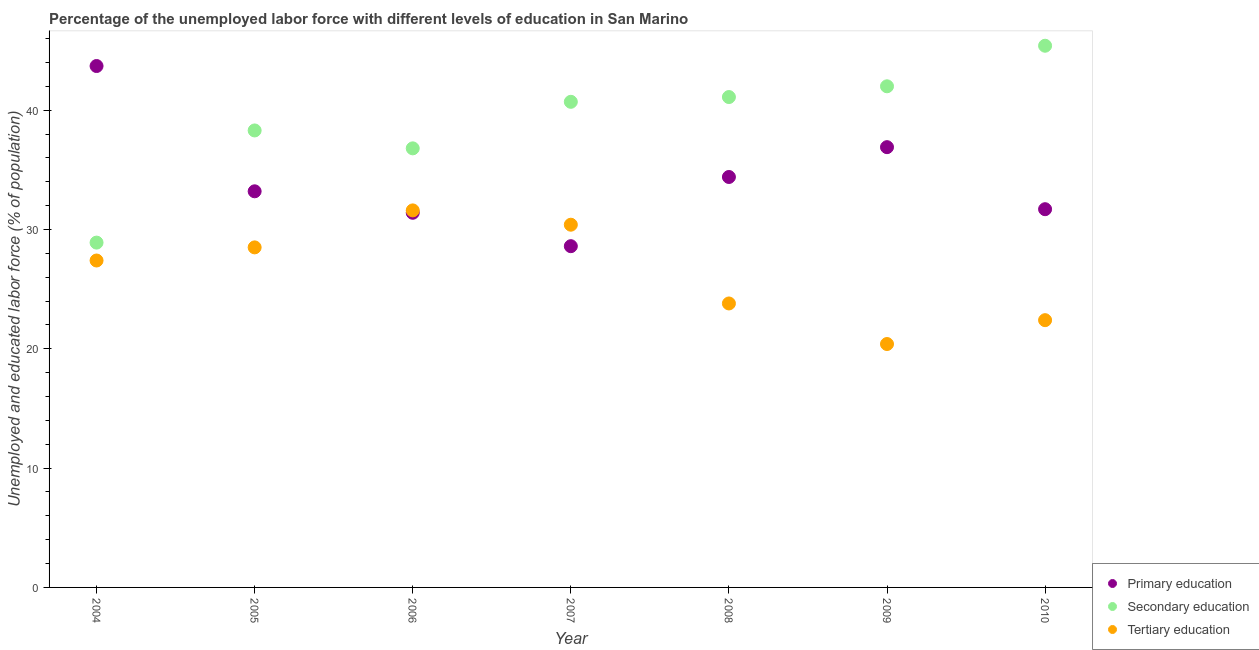Is the number of dotlines equal to the number of legend labels?
Offer a terse response. Yes. What is the percentage of labor force who received tertiary education in 2006?
Ensure brevity in your answer.  31.6. Across all years, what is the maximum percentage of labor force who received tertiary education?
Provide a succinct answer. 31.6. Across all years, what is the minimum percentage of labor force who received secondary education?
Keep it short and to the point. 28.9. In which year was the percentage of labor force who received tertiary education maximum?
Keep it short and to the point. 2006. In which year was the percentage of labor force who received primary education minimum?
Offer a very short reply. 2007. What is the total percentage of labor force who received secondary education in the graph?
Your response must be concise. 273.2. What is the difference between the percentage of labor force who received primary education in 2004 and that in 2006?
Your answer should be very brief. 12.3. What is the difference between the percentage of labor force who received tertiary education in 2007 and the percentage of labor force who received secondary education in 2006?
Provide a short and direct response. -6.4. What is the average percentage of labor force who received tertiary education per year?
Keep it short and to the point. 26.36. In the year 2004, what is the difference between the percentage of labor force who received tertiary education and percentage of labor force who received secondary education?
Provide a succinct answer. -1.5. In how many years, is the percentage of labor force who received primary education greater than 28 %?
Your answer should be compact. 7. What is the ratio of the percentage of labor force who received secondary education in 2005 to that in 2007?
Provide a short and direct response. 0.94. What is the difference between the highest and the second highest percentage of labor force who received primary education?
Offer a terse response. 6.8. What is the difference between the highest and the lowest percentage of labor force who received primary education?
Make the answer very short. 15.1. Is it the case that in every year, the sum of the percentage of labor force who received primary education and percentage of labor force who received secondary education is greater than the percentage of labor force who received tertiary education?
Your answer should be very brief. Yes. Does the percentage of labor force who received tertiary education monotonically increase over the years?
Offer a very short reply. No. Are the values on the major ticks of Y-axis written in scientific E-notation?
Provide a short and direct response. No. Does the graph contain grids?
Your response must be concise. No. Where does the legend appear in the graph?
Give a very brief answer. Bottom right. What is the title of the graph?
Offer a terse response. Percentage of the unemployed labor force with different levels of education in San Marino. What is the label or title of the X-axis?
Provide a short and direct response. Year. What is the label or title of the Y-axis?
Provide a short and direct response. Unemployed and educated labor force (% of population). What is the Unemployed and educated labor force (% of population) of Primary education in 2004?
Give a very brief answer. 43.7. What is the Unemployed and educated labor force (% of population) of Secondary education in 2004?
Provide a short and direct response. 28.9. What is the Unemployed and educated labor force (% of population) in Tertiary education in 2004?
Keep it short and to the point. 27.4. What is the Unemployed and educated labor force (% of population) of Primary education in 2005?
Offer a terse response. 33.2. What is the Unemployed and educated labor force (% of population) in Secondary education in 2005?
Your response must be concise. 38.3. What is the Unemployed and educated labor force (% of population) in Tertiary education in 2005?
Your response must be concise. 28.5. What is the Unemployed and educated labor force (% of population) in Primary education in 2006?
Give a very brief answer. 31.4. What is the Unemployed and educated labor force (% of population) in Secondary education in 2006?
Give a very brief answer. 36.8. What is the Unemployed and educated labor force (% of population) of Tertiary education in 2006?
Your answer should be very brief. 31.6. What is the Unemployed and educated labor force (% of population) in Primary education in 2007?
Your answer should be compact. 28.6. What is the Unemployed and educated labor force (% of population) of Secondary education in 2007?
Provide a short and direct response. 40.7. What is the Unemployed and educated labor force (% of population) in Tertiary education in 2007?
Give a very brief answer. 30.4. What is the Unemployed and educated labor force (% of population) in Primary education in 2008?
Provide a succinct answer. 34.4. What is the Unemployed and educated labor force (% of population) in Secondary education in 2008?
Your response must be concise. 41.1. What is the Unemployed and educated labor force (% of population) in Tertiary education in 2008?
Provide a succinct answer. 23.8. What is the Unemployed and educated labor force (% of population) in Primary education in 2009?
Make the answer very short. 36.9. What is the Unemployed and educated labor force (% of population) of Secondary education in 2009?
Provide a short and direct response. 42. What is the Unemployed and educated labor force (% of population) of Tertiary education in 2009?
Make the answer very short. 20.4. What is the Unemployed and educated labor force (% of population) in Primary education in 2010?
Your answer should be compact. 31.7. What is the Unemployed and educated labor force (% of population) of Secondary education in 2010?
Keep it short and to the point. 45.4. What is the Unemployed and educated labor force (% of population) in Tertiary education in 2010?
Give a very brief answer. 22.4. Across all years, what is the maximum Unemployed and educated labor force (% of population) of Primary education?
Your answer should be very brief. 43.7. Across all years, what is the maximum Unemployed and educated labor force (% of population) in Secondary education?
Offer a very short reply. 45.4. Across all years, what is the maximum Unemployed and educated labor force (% of population) of Tertiary education?
Your answer should be very brief. 31.6. Across all years, what is the minimum Unemployed and educated labor force (% of population) in Primary education?
Provide a succinct answer. 28.6. Across all years, what is the minimum Unemployed and educated labor force (% of population) in Secondary education?
Offer a terse response. 28.9. Across all years, what is the minimum Unemployed and educated labor force (% of population) of Tertiary education?
Offer a very short reply. 20.4. What is the total Unemployed and educated labor force (% of population) of Primary education in the graph?
Provide a succinct answer. 239.9. What is the total Unemployed and educated labor force (% of population) in Secondary education in the graph?
Provide a succinct answer. 273.2. What is the total Unemployed and educated labor force (% of population) in Tertiary education in the graph?
Provide a succinct answer. 184.5. What is the difference between the Unemployed and educated labor force (% of population) of Secondary education in 2004 and that in 2005?
Your answer should be very brief. -9.4. What is the difference between the Unemployed and educated labor force (% of population) in Tertiary education in 2004 and that in 2005?
Keep it short and to the point. -1.1. What is the difference between the Unemployed and educated labor force (% of population) of Primary education in 2004 and that in 2006?
Provide a succinct answer. 12.3. What is the difference between the Unemployed and educated labor force (% of population) in Tertiary education in 2004 and that in 2006?
Offer a very short reply. -4.2. What is the difference between the Unemployed and educated labor force (% of population) in Primary education in 2004 and that in 2007?
Provide a short and direct response. 15.1. What is the difference between the Unemployed and educated labor force (% of population) in Secondary education in 2004 and that in 2007?
Ensure brevity in your answer.  -11.8. What is the difference between the Unemployed and educated labor force (% of population) of Primary education in 2004 and that in 2008?
Ensure brevity in your answer.  9.3. What is the difference between the Unemployed and educated labor force (% of population) of Primary education in 2004 and that in 2010?
Provide a succinct answer. 12. What is the difference between the Unemployed and educated labor force (% of population) of Secondary education in 2004 and that in 2010?
Your answer should be very brief. -16.5. What is the difference between the Unemployed and educated labor force (% of population) of Tertiary education in 2004 and that in 2010?
Offer a terse response. 5. What is the difference between the Unemployed and educated labor force (% of population) of Primary education in 2005 and that in 2006?
Your answer should be very brief. 1.8. What is the difference between the Unemployed and educated labor force (% of population) in Secondary education in 2005 and that in 2006?
Make the answer very short. 1.5. What is the difference between the Unemployed and educated labor force (% of population) of Primary education in 2005 and that in 2007?
Offer a terse response. 4.6. What is the difference between the Unemployed and educated labor force (% of population) in Secondary education in 2005 and that in 2007?
Your answer should be very brief. -2.4. What is the difference between the Unemployed and educated labor force (% of population) in Secondary education in 2005 and that in 2008?
Provide a succinct answer. -2.8. What is the difference between the Unemployed and educated labor force (% of population) of Primary education in 2006 and that in 2007?
Provide a succinct answer. 2.8. What is the difference between the Unemployed and educated labor force (% of population) of Secondary education in 2006 and that in 2007?
Your answer should be very brief. -3.9. What is the difference between the Unemployed and educated labor force (% of population) of Tertiary education in 2006 and that in 2007?
Your answer should be very brief. 1.2. What is the difference between the Unemployed and educated labor force (% of population) of Primary education in 2006 and that in 2008?
Your answer should be very brief. -3. What is the difference between the Unemployed and educated labor force (% of population) of Secondary education in 2006 and that in 2008?
Keep it short and to the point. -4.3. What is the difference between the Unemployed and educated labor force (% of population) of Primary education in 2006 and that in 2009?
Your answer should be compact. -5.5. What is the difference between the Unemployed and educated labor force (% of population) of Tertiary education in 2006 and that in 2009?
Your answer should be very brief. 11.2. What is the difference between the Unemployed and educated labor force (% of population) of Secondary education in 2006 and that in 2010?
Offer a terse response. -8.6. What is the difference between the Unemployed and educated labor force (% of population) of Primary education in 2007 and that in 2008?
Your response must be concise. -5.8. What is the difference between the Unemployed and educated labor force (% of population) in Primary education in 2007 and that in 2009?
Give a very brief answer. -8.3. What is the difference between the Unemployed and educated labor force (% of population) in Secondary education in 2007 and that in 2009?
Keep it short and to the point. -1.3. What is the difference between the Unemployed and educated labor force (% of population) of Tertiary education in 2007 and that in 2009?
Provide a succinct answer. 10. What is the difference between the Unemployed and educated labor force (% of population) of Secondary education in 2007 and that in 2010?
Provide a succinct answer. -4.7. What is the difference between the Unemployed and educated labor force (% of population) of Primary education in 2008 and that in 2009?
Keep it short and to the point. -2.5. What is the difference between the Unemployed and educated labor force (% of population) of Secondary education in 2008 and that in 2009?
Offer a very short reply. -0.9. What is the difference between the Unemployed and educated labor force (% of population) in Primary education in 2008 and that in 2010?
Give a very brief answer. 2.7. What is the difference between the Unemployed and educated labor force (% of population) of Tertiary education in 2008 and that in 2010?
Keep it short and to the point. 1.4. What is the difference between the Unemployed and educated labor force (% of population) in Primary education in 2004 and the Unemployed and educated labor force (% of population) in Tertiary education in 2005?
Ensure brevity in your answer.  15.2. What is the difference between the Unemployed and educated labor force (% of population) of Secondary education in 2004 and the Unemployed and educated labor force (% of population) of Tertiary education in 2005?
Your answer should be very brief. 0.4. What is the difference between the Unemployed and educated labor force (% of population) in Primary education in 2004 and the Unemployed and educated labor force (% of population) in Secondary education in 2006?
Provide a short and direct response. 6.9. What is the difference between the Unemployed and educated labor force (% of population) in Primary education in 2004 and the Unemployed and educated labor force (% of population) in Tertiary education in 2006?
Your answer should be compact. 12.1. What is the difference between the Unemployed and educated labor force (% of population) in Secondary education in 2004 and the Unemployed and educated labor force (% of population) in Tertiary education in 2006?
Provide a succinct answer. -2.7. What is the difference between the Unemployed and educated labor force (% of population) in Primary education in 2004 and the Unemployed and educated labor force (% of population) in Secondary education in 2007?
Your answer should be compact. 3. What is the difference between the Unemployed and educated labor force (% of population) in Primary education in 2004 and the Unemployed and educated labor force (% of population) in Secondary education in 2009?
Provide a short and direct response. 1.7. What is the difference between the Unemployed and educated labor force (% of population) in Primary education in 2004 and the Unemployed and educated labor force (% of population) in Tertiary education in 2009?
Your response must be concise. 23.3. What is the difference between the Unemployed and educated labor force (% of population) of Secondary education in 2004 and the Unemployed and educated labor force (% of population) of Tertiary education in 2009?
Make the answer very short. 8.5. What is the difference between the Unemployed and educated labor force (% of population) in Primary education in 2004 and the Unemployed and educated labor force (% of population) in Secondary education in 2010?
Your response must be concise. -1.7. What is the difference between the Unemployed and educated labor force (% of population) of Primary education in 2004 and the Unemployed and educated labor force (% of population) of Tertiary education in 2010?
Make the answer very short. 21.3. What is the difference between the Unemployed and educated labor force (% of population) of Secondary education in 2005 and the Unemployed and educated labor force (% of population) of Tertiary education in 2006?
Offer a very short reply. 6.7. What is the difference between the Unemployed and educated labor force (% of population) in Primary education in 2005 and the Unemployed and educated labor force (% of population) in Secondary education in 2007?
Your response must be concise. -7.5. What is the difference between the Unemployed and educated labor force (% of population) of Secondary education in 2005 and the Unemployed and educated labor force (% of population) of Tertiary education in 2007?
Give a very brief answer. 7.9. What is the difference between the Unemployed and educated labor force (% of population) in Primary education in 2005 and the Unemployed and educated labor force (% of population) in Secondary education in 2008?
Offer a very short reply. -7.9. What is the difference between the Unemployed and educated labor force (% of population) of Primary education in 2005 and the Unemployed and educated labor force (% of population) of Secondary education in 2009?
Your response must be concise. -8.8. What is the difference between the Unemployed and educated labor force (% of population) of Secondary education in 2005 and the Unemployed and educated labor force (% of population) of Tertiary education in 2009?
Give a very brief answer. 17.9. What is the difference between the Unemployed and educated labor force (% of population) in Primary education in 2005 and the Unemployed and educated labor force (% of population) in Secondary education in 2010?
Give a very brief answer. -12.2. What is the difference between the Unemployed and educated labor force (% of population) of Primary education in 2006 and the Unemployed and educated labor force (% of population) of Secondary education in 2007?
Offer a very short reply. -9.3. What is the difference between the Unemployed and educated labor force (% of population) of Primary education in 2006 and the Unemployed and educated labor force (% of population) of Tertiary education in 2007?
Ensure brevity in your answer.  1. What is the difference between the Unemployed and educated labor force (% of population) of Primary education in 2006 and the Unemployed and educated labor force (% of population) of Tertiary education in 2008?
Offer a terse response. 7.6. What is the difference between the Unemployed and educated labor force (% of population) of Primary education in 2006 and the Unemployed and educated labor force (% of population) of Tertiary education in 2009?
Offer a terse response. 11. What is the difference between the Unemployed and educated labor force (% of population) of Primary education in 2006 and the Unemployed and educated labor force (% of population) of Secondary education in 2010?
Provide a succinct answer. -14. What is the difference between the Unemployed and educated labor force (% of population) in Secondary education in 2006 and the Unemployed and educated labor force (% of population) in Tertiary education in 2010?
Offer a very short reply. 14.4. What is the difference between the Unemployed and educated labor force (% of population) of Primary education in 2007 and the Unemployed and educated labor force (% of population) of Secondary education in 2008?
Provide a succinct answer. -12.5. What is the difference between the Unemployed and educated labor force (% of population) of Secondary education in 2007 and the Unemployed and educated labor force (% of population) of Tertiary education in 2008?
Your response must be concise. 16.9. What is the difference between the Unemployed and educated labor force (% of population) of Primary education in 2007 and the Unemployed and educated labor force (% of population) of Secondary education in 2009?
Provide a short and direct response. -13.4. What is the difference between the Unemployed and educated labor force (% of population) of Primary education in 2007 and the Unemployed and educated labor force (% of population) of Tertiary education in 2009?
Your answer should be compact. 8.2. What is the difference between the Unemployed and educated labor force (% of population) of Secondary education in 2007 and the Unemployed and educated labor force (% of population) of Tertiary education in 2009?
Provide a succinct answer. 20.3. What is the difference between the Unemployed and educated labor force (% of population) in Primary education in 2007 and the Unemployed and educated labor force (% of population) in Secondary education in 2010?
Provide a succinct answer. -16.8. What is the difference between the Unemployed and educated labor force (% of population) of Secondary education in 2007 and the Unemployed and educated labor force (% of population) of Tertiary education in 2010?
Your response must be concise. 18.3. What is the difference between the Unemployed and educated labor force (% of population) of Primary education in 2008 and the Unemployed and educated labor force (% of population) of Secondary education in 2009?
Your answer should be compact. -7.6. What is the difference between the Unemployed and educated labor force (% of population) in Secondary education in 2008 and the Unemployed and educated labor force (% of population) in Tertiary education in 2009?
Offer a terse response. 20.7. What is the difference between the Unemployed and educated labor force (% of population) of Primary education in 2008 and the Unemployed and educated labor force (% of population) of Tertiary education in 2010?
Your answer should be compact. 12. What is the difference between the Unemployed and educated labor force (% of population) in Primary education in 2009 and the Unemployed and educated labor force (% of population) in Tertiary education in 2010?
Your answer should be compact. 14.5. What is the difference between the Unemployed and educated labor force (% of population) of Secondary education in 2009 and the Unemployed and educated labor force (% of population) of Tertiary education in 2010?
Your answer should be compact. 19.6. What is the average Unemployed and educated labor force (% of population) in Primary education per year?
Offer a terse response. 34.27. What is the average Unemployed and educated labor force (% of population) of Secondary education per year?
Your response must be concise. 39.03. What is the average Unemployed and educated labor force (% of population) in Tertiary education per year?
Your answer should be very brief. 26.36. In the year 2004, what is the difference between the Unemployed and educated labor force (% of population) in Primary education and Unemployed and educated labor force (% of population) in Secondary education?
Your answer should be very brief. 14.8. In the year 2004, what is the difference between the Unemployed and educated labor force (% of population) of Secondary education and Unemployed and educated labor force (% of population) of Tertiary education?
Your answer should be very brief. 1.5. In the year 2005, what is the difference between the Unemployed and educated labor force (% of population) of Primary education and Unemployed and educated labor force (% of population) of Secondary education?
Give a very brief answer. -5.1. In the year 2005, what is the difference between the Unemployed and educated labor force (% of population) of Primary education and Unemployed and educated labor force (% of population) of Tertiary education?
Make the answer very short. 4.7. In the year 2006, what is the difference between the Unemployed and educated labor force (% of population) in Primary education and Unemployed and educated labor force (% of population) in Secondary education?
Provide a succinct answer. -5.4. In the year 2006, what is the difference between the Unemployed and educated labor force (% of population) of Primary education and Unemployed and educated labor force (% of population) of Tertiary education?
Give a very brief answer. -0.2. In the year 2006, what is the difference between the Unemployed and educated labor force (% of population) in Secondary education and Unemployed and educated labor force (% of population) in Tertiary education?
Your response must be concise. 5.2. In the year 2007, what is the difference between the Unemployed and educated labor force (% of population) in Primary education and Unemployed and educated labor force (% of population) in Secondary education?
Your answer should be compact. -12.1. In the year 2007, what is the difference between the Unemployed and educated labor force (% of population) of Primary education and Unemployed and educated labor force (% of population) of Tertiary education?
Your response must be concise. -1.8. In the year 2007, what is the difference between the Unemployed and educated labor force (% of population) of Secondary education and Unemployed and educated labor force (% of population) of Tertiary education?
Ensure brevity in your answer.  10.3. In the year 2008, what is the difference between the Unemployed and educated labor force (% of population) of Primary education and Unemployed and educated labor force (% of population) of Tertiary education?
Provide a succinct answer. 10.6. In the year 2009, what is the difference between the Unemployed and educated labor force (% of population) of Primary education and Unemployed and educated labor force (% of population) of Secondary education?
Offer a very short reply. -5.1. In the year 2009, what is the difference between the Unemployed and educated labor force (% of population) in Secondary education and Unemployed and educated labor force (% of population) in Tertiary education?
Your answer should be very brief. 21.6. In the year 2010, what is the difference between the Unemployed and educated labor force (% of population) of Primary education and Unemployed and educated labor force (% of population) of Secondary education?
Offer a very short reply. -13.7. In the year 2010, what is the difference between the Unemployed and educated labor force (% of population) in Primary education and Unemployed and educated labor force (% of population) in Tertiary education?
Ensure brevity in your answer.  9.3. In the year 2010, what is the difference between the Unemployed and educated labor force (% of population) of Secondary education and Unemployed and educated labor force (% of population) of Tertiary education?
Give a very brief answer. 23. What is the ratio of the Unemployed and educated labor force (% of population) in Primary education in 2004 to that in 2005?
Keep it short and to the point. 1.32. What is the ratio of the Unemployed and educated labor force (% of population) of Secondary education in 2004 to that in 2005?
Ensure brevity in your answer.  0.75. What is the ratio of the Unemployed and educated labor force (% of population) in Tertiary education in 2004 to that in 2005?
Provide a short and direct response. 0.96. What is the ratio of the Unemployed and educated labor force (% of population) of Primary education in 2004 to that in 2006?
Keep it short and to the point. 1.39. What is the ratio of the Unemployed and educated labor force (% of population) of Secondary education in 2004 to that in 2006?
Provide a succinct answer. 0.79. What is the ratio of the Unemployed and educated labor force (% of population) of Tertiary education in 2004 to that in 2006?
Make the answer very short. 0.87. What is the ratio of the Unemployed and educated labor force (% of population) of Primary education in 2004 to that in 2007?
Ensure brevity in your answer.  1.53. What is the ratio of the Unemployed and educated labor force (% of population) of Secondary education in 2004 to that in 2007?
Your answer should be compact. 0.71. What is the ratio of the Unemployed and educated labor force (% of population) in Tertiary education in 2004 to that in 2007?
Provide a short and direct response. 0.9. What is the ratio of the Unemployed and educated labor force (% of population) of Primary education in 2004 to that in 2008?
Offer a terse response. 1.27. What is the ratio of the Unemployed and educated labor force (% of population) of Secondary education in 2004 to that in 2008?
Offer a terse response. 0.7. What is the ratio of the Unemployed and educated labor force (% of population) of Tertiary education in 2004 to that in 2008?
Ensure brevity in your answer.  1.15. What is the ratio of the Unemployed and educated labor force (% of population) in Primary education in 2004 to that in 2009?
Provide a short and direct response. 1.18. What is the ratio of the Unemployed and educated labor force (% of population) of Secondary education in 2004 to that in 2009?
Provide a short and direct response. 0.69. What is the ratio of the Unemployed and educated labor force (% of population) of Tertiary education in 2004 to that in 2009?
Make the answer very short. 1.34. What is the ratio of the Unemployed and educated labor force (% of population) of Primary education in 2004 to that in 2010?
Give a very brief answer. 1.38. What is the ratio of the Unemployed and educated labor force (% of population) in Secondary education in 2004 to that in 2010?
Offer a terse response. 0.64. What is the ratio of the Unemployed and educated labor force (% of population) in Tertiary education in 2004 to that in 2010?
Give a very brief answer. 1.22. What is the ratio of the Unemployed and educated labor force (% of population) in Primary education in 2005 to that in 2006?
Provide a succinct answer. 1.06. What is the ratio of the Unemployed and educated labor force (% of population) of Secondary education in 2005 to that in 2006?
Keep it short and to the point. 1.04. What is the ratio of the Unemployed and educated labor force (% of population) in Tertiary education in 2005 to that in 2006?
Offer a terse response. 0.9. What is the ratio of the Unemployed and educated labor force (% of population) of Primary education in 2005 to that in 2007?
Your answer should be compact. 1.16. What is the ratio of the Unemployed and educated labor force (% of population) in Secondary education in 2005 to that in 2007?
Your answer should be compact. 0.94. What is the ratio of the Unemployed and educated labor force (% of population) of Primary education in 2005 to that in 2008?
Offer a terse response. 0.97. What is the ratio of the Unemployed and educated labor force (% of population) of Secondary education in 2005 to that in 2008?
Offer a terse response. 0.93. What is the ratio of the Unemployed and educated labor force (% of population) in Tertiary education in 2005 to that in 2008?
Make the answer very short. 1.2. What is the ratio of the Unemployed and educated labor force (% of population) of Primary education in 2005 to that in 2009?
Your response must be concise. 0.9. What is the ratio of the Unemployed and educated labor force (% of population) in Secondary education in 2005 to that in 2009?
Your answer should be compact. 0.91. What is the ratio of the Unemployed and educated labor force (% of population) in Tertiary education in 2005 to that in 2009?
Your answer should be compact. 1.4. What is the ratio of the Unemployed and educated labor force (% of population) of Primary education in 2005 to that in 2010?
Keep it short and to the point. 1.05. What is the ratio of the Unemployed and educated labor force (% of population) of Secondary education in 2005 to that in 2010?
Your answer should be compact. 0.84. What is the ratio of the Unemployed and educated labor force (% of population) in Tertiary education in 2005 to that in 2010?
Your answer should be very brief. 1.27. What is the ratio of the Unemployed and educated labor force (% of population) in Primary education in 2006 to that in 2007?
Make the answer very short. 1.1. What is the ratio of the Unemployed and educated labor force (% of population) in Secondary education in 2006 to that in 2007?
Your answer should be compact. 0.9. What is the ratio of the Unemployed and educated labor force (% of population) in Tertiary education in 2006 to that in 2007?
Your answer should be compact. 1.04. What is the ratio of the Unemployed and educated labor force (% of population) in Primary education in 2006 to that in 2008?
Offer a very short reply. 0.91. What is the ratio of the Unemployed and educated labor force (% of population) in Secondary education in 2006 to that in 2008?
Keep it short and to the point. 0.9. What is the ratio of the Unemployed and educated labor force (% of population) of Tertiary education in 2006 to that in 2008?
Provide a succinct answer. 1.33. What is the ratio of the Unemployed and educated labor force (% of population) in Primary education in 2006 to that in 2009?
Give a very brief answer. 0.85. What is the ratio of the Unemployed and educated labor force (% of population) in Secondary education in 2006 to that in 2009?
Your response must be concise. 0.88. What is the ratio of the Unemployed and educated labor force (% of population) in Tertiary education in 2006 to that in 2009?
Your answer should be compact. 1.55. What is the ratio of the Unemployed and educated labor force (% of population) in Secondary education in 2006 to that in 2010?
Provide a succinct answer. 0.81. What is the ratio of the Unemployed and educated labor force (% of population) of Tertiary education in 2006 to that in 2010?
Make the answer very short. 1.41. What is the ratio of the Unemployed and educated labor force (% of population) of Primary education in 2007 to that in 2008?
Provide a succinct answer. 0.83. What is the ratio of the Unemployed and educated labor force (% of population) in Secondary education in 2007 to that in 2008?
Your answer should be very brief. 0.99. What is the ratio of the Unemployed and educated labor force (% of population) in Tertiary education in 2007 to that in 2008?
Keep it short and to the point. 1.28. What is the ratio of the Unemployed and educated labor force (% of population) of Primary education in 2007 to that in 2009?
Offer a very short reply. 0.78. What is the ratio of the Unemployed and educated labor force (% of population) of Tertiary education in 2007 to that in 2009?
Keep it short and to the point. 1.49. What is the ratio of the Unemployed and educated labor force (% of population) of Primary education in 2007 to that in 2010?
Provide a succinct answer. 0.9. What is the ratio of the Unemployed and educated labor force (% of population) of Secondary education in 2007 to that in 2010?
Your response must be concise. 0.9. What is the ratio of the Unemployed and educated labor force (% of population) in Tertiary education in 2007 to that in 2010?
Provide a short and direct response. 1.36. What is the ratio of the Unemployed and educated labor force (% of population) in Primary education in 2008 to that in 2009?
Offer a very short reply. 0.93. What is the ratio of the Unemployed and educated labor force (% of population) of Secondary education in 2008 to that in 2009?
Offer a terse response. 0.98. What is the ratio of the Unemployed and educated labor force (% of population) of Primary education in 2008 to that in 2010?
Make the answer very short. 1.09. What is the ratio of the Unemployed and educated labor force (% of population) of Secondary education in 2008 to that in 2010?
Your answer should be very brief. 0.91. What is the ratio of the Unemployed and educated labor force (% of population) in Primary education in 2009 to that in 2010?
Give a very brief answer. 1.16. What is the ratio of the Unemployed and educated labor force (% of population) in Secondary education in 2009 to that in 2010?
Offer a terse response. 0.93. What is the ratio of the Unemployed and educated labor force (% of population) in Tertiary education in 2009 to that in 2010?
Provide a short and direct response. 0.91. What is the difference between the highest and the second highest Unemployed and educated labor force (% of population) of Primary education?
Your answer should be compact. 6.8. What is the difference between the highest and the second highest Unemployed and educated labor force (% of population) of Secondary education?
Offer a terse response. 3.4. What is the difference between the highest and the second highest Unemployed and educated labor force (% of population) in Tertiary education?
Provide a short and direct response. 1.2. What is the difference between the highest and the lowest Unemployed and educated labor force (% of population) in Secondary education?
Your answer should be compact. 16.5. What is the difference between the highest and the lowest Unemployed and educated labor force (% of population) in Tertiary education?
Make the answer very short. 11.2. 